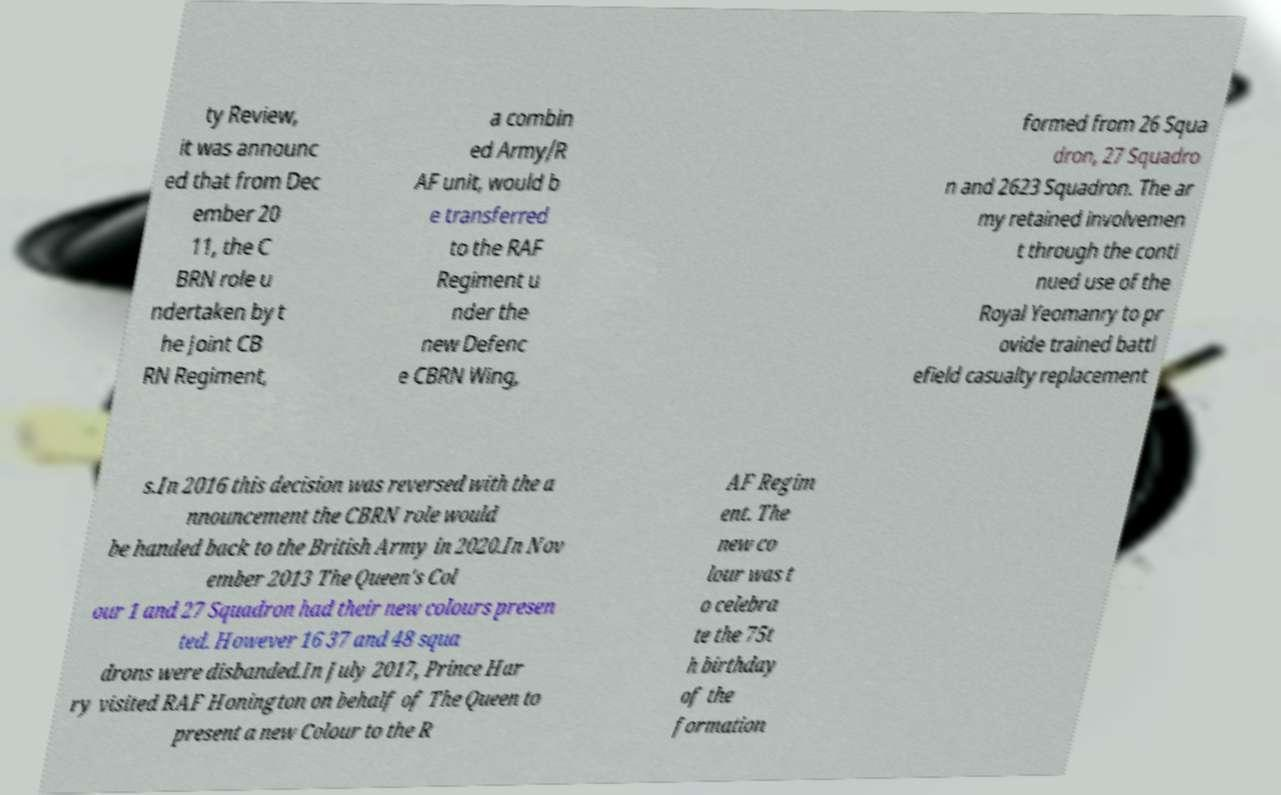There's text embedded in this image that I need extracted. Can you transcribe it verbatim? ty Review, it was announc ed that from Dec ember 20 11, the C BRN role u ndertaken by t he Joint CB RN Regiment, a combin ed Army/R AF unit, would b e transferred to the RAF Regiment u nder the new Defenc e CBRN Wing, formed from 26 Squa dron, 27 Squadro n and 2623 Squadron. The ar my retained involvemen t through the conti nued use of the Royal Yeomanry to pr ovide trained battl efield casualty replacement s.In 2016 this decision was reversed with the a nnouncement the CBRN role would be handed back to the British Army in 2020.In Nov ember 2013 The Queen's Col our 1 and 27 Squadron had their new colours presen ted. However 16 37 and 48 squa drons were disbanded.In July 2017, Prince Har ry visited RAF Honington on behalf of The Queen to present a new Colour to the R AF Regim ent. The new co lour was t o celebra te the 75t h birthday of the formation 